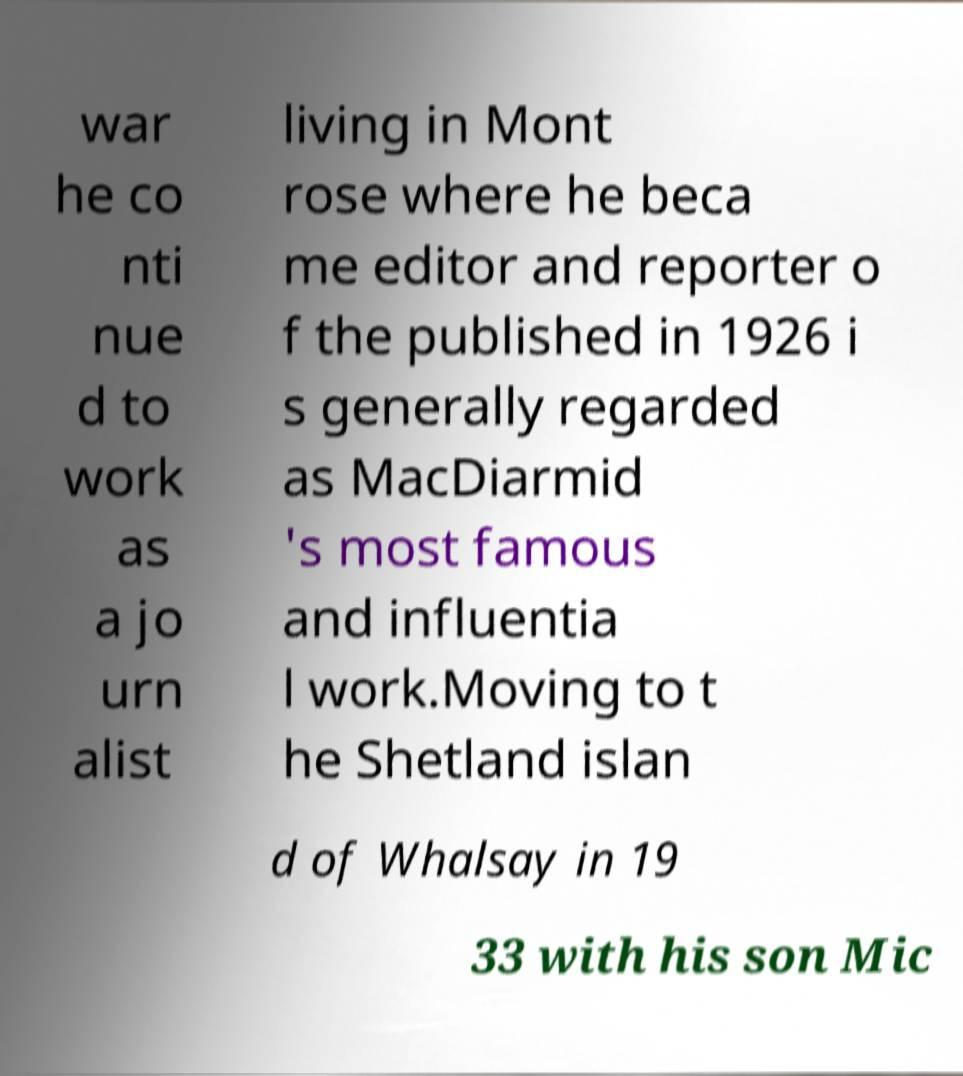Could you assist in decoding the text presented in this image and type it out clearly? war he co nti nue d to work as a jo urn alist living in Mont rose where he beca me editor and reporter o f the published in 1926 i s generally regarded as MacDiarmid 's most famous and influentia l work.Moving to t he Shetland islan d of Whalsay in 19 33 with his son Mic 